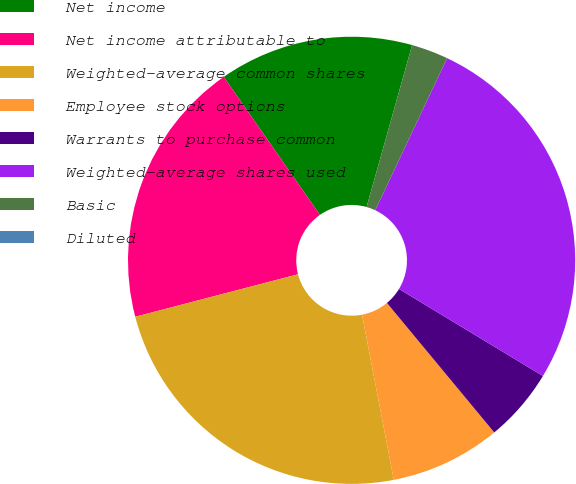Convert chart to OTSL. <chart><loc_0><loc_0><loc_500><loc_500><pie_chart><fcel>Net income<fcel>Net income attributable to<fcel>Weighted-average common shares<fcel>Employee stock options<fcel>Warrants to purchase common<fcel>Weighted-average shares used<fcel>Basic<fcel>Diluted<nl><fcel>14.05%<fcel>19.37%<fcel>23.96%<fcel>7.99%<fcel>5.33%<fcel>26.63%<fcel>2.66%<fcel>0.0%<nl></chart> 